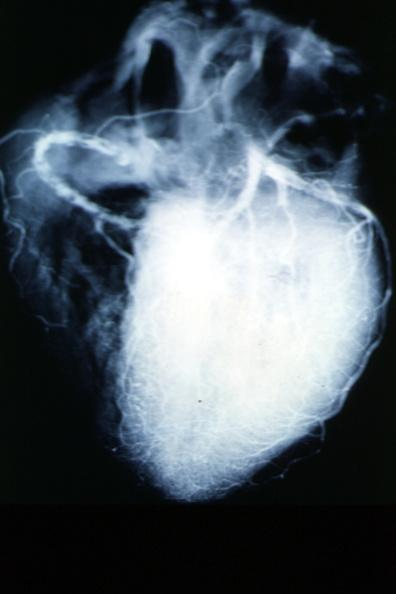s stillborn cord around neck present?
Answer the question using a single word or phrase. No 